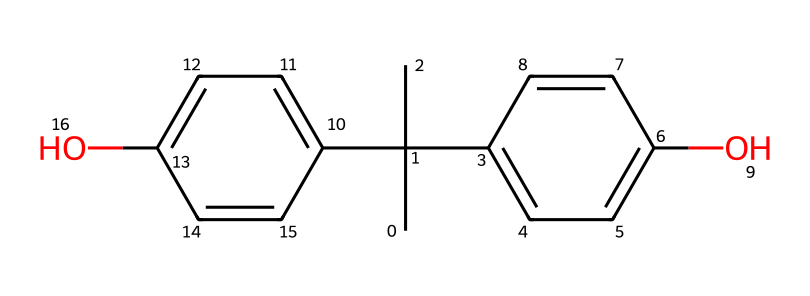What is the main functional group present in this chemical? The chemical structure contains multiple hydroxyl (-OH) groups, which are characteristic of phenolic compounds. These functional groups can be identified on the aromatic rings indicated in the SMILES representation.
Answer: hydroxyl group How many carbon atoms are present in the structure? By analyzing the SMILES representation, we can count the number of carbon atoms. The groups and rings indicate a total of 15 carbon atoms in the entire structure.
Answer: 15 What is the molecular formula of this chemical? Starting from the counted atoms, the chemical's molecular composition can be summarized: 15 carbon (C), 16 hydrogen (H), and 2 oxygen (O), leading to a molecular formula of C15H16O2.
Answer: C15H16O2 Does this chemical contain any aromatic rings? The presence of the letters 'C' in the format of 'C1=CC=C(...)' indicates that there are cyclic structures with alternating double bonds, which are typical of aromatic rings. This confirms the existence of two aromatic rings in the chemical.
Answer: yes What type of chemical compound is bisphenol A? The presence of hydroxyl groups and the specific arrangement of the carbon skeleton signifies that bisphenol A is classified as a phenolic compound, which further implies its properties and reactivity in various applications.
Answer: phenolic compound How many hydroxyl groups are in the structure of bisphenol A? By close examination of the structure as per the SMILES notation, there are two visibly identified -OH groups attached to the aromatic rings, indicating the presence of two hydroxyl groups.
Answer: 2 